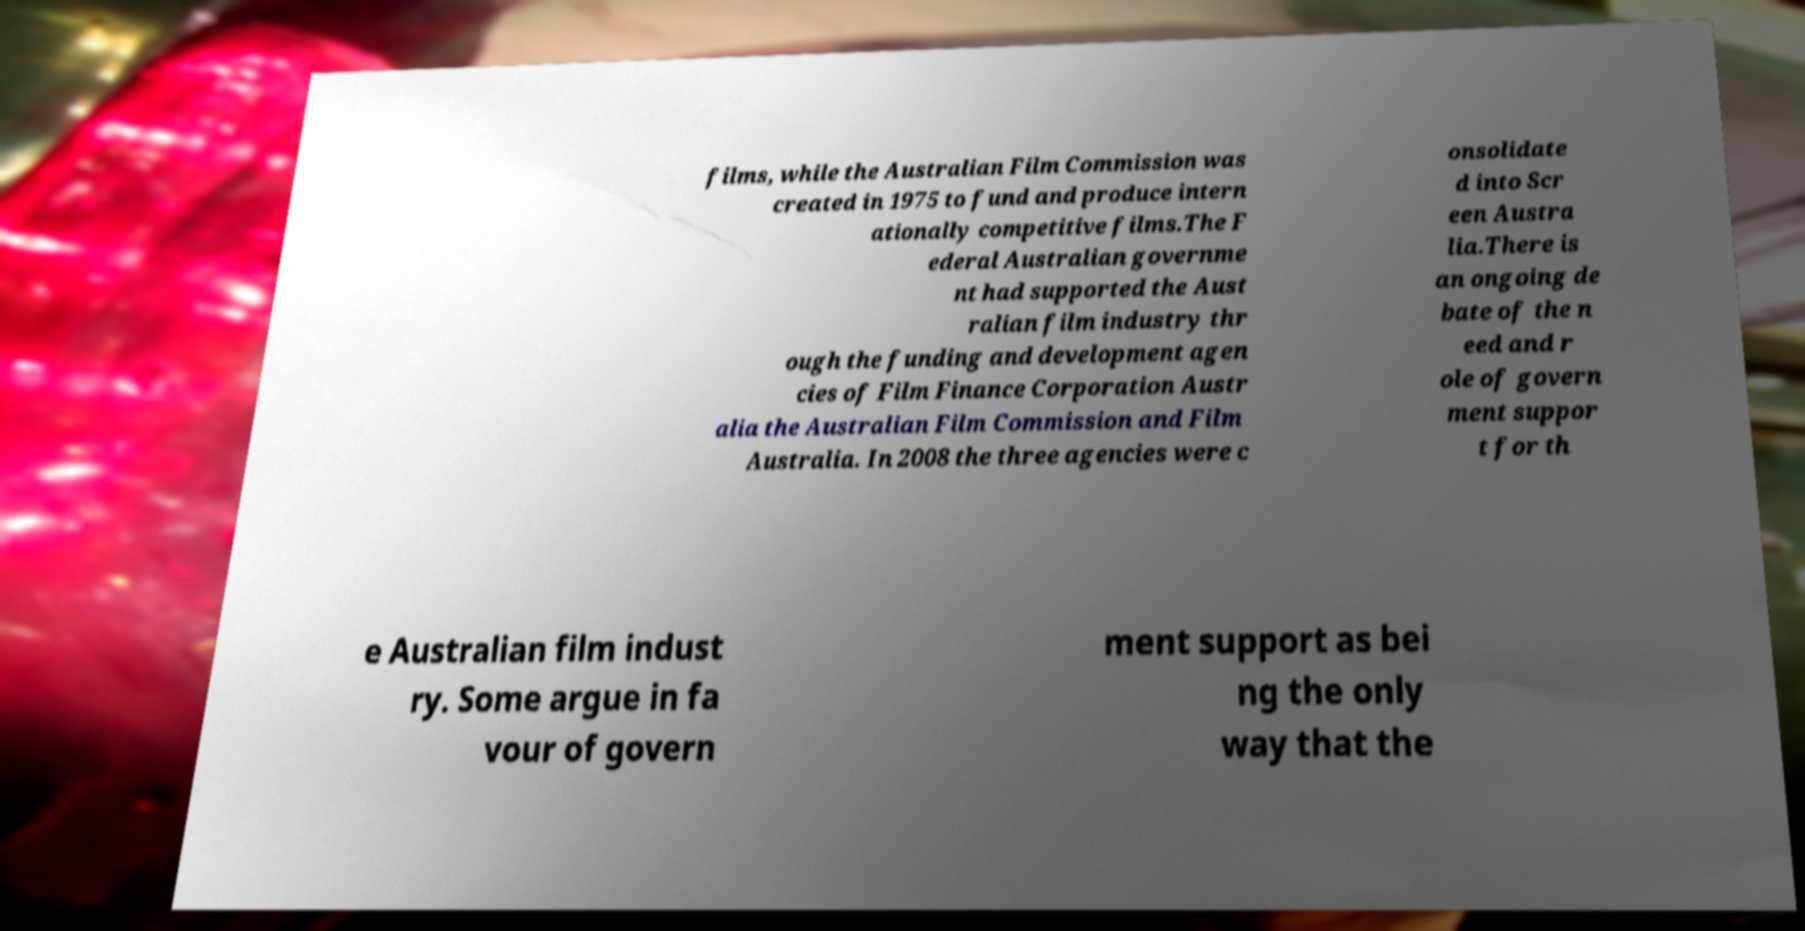Please identify and transcribe the text found in this image. films, while the Australian Film Commission was created in 1975 to fund and produce intern ationally competitive films.The F ederal Australian governme nt had supported the Aust ralian film industry thr ough the funding and development agen cies of Film Finance Corporation Austr alia the Australian Film Commission and Film Australia. In 2008 the three agencies were c onsolidate d into Scr een Austra lia.There is an ongoing de bate of the n eed and r ole of govern ment suppor t for th e Australian film indust ry. Some argue in fa vour of govern ment support as bei ng the only way that the 